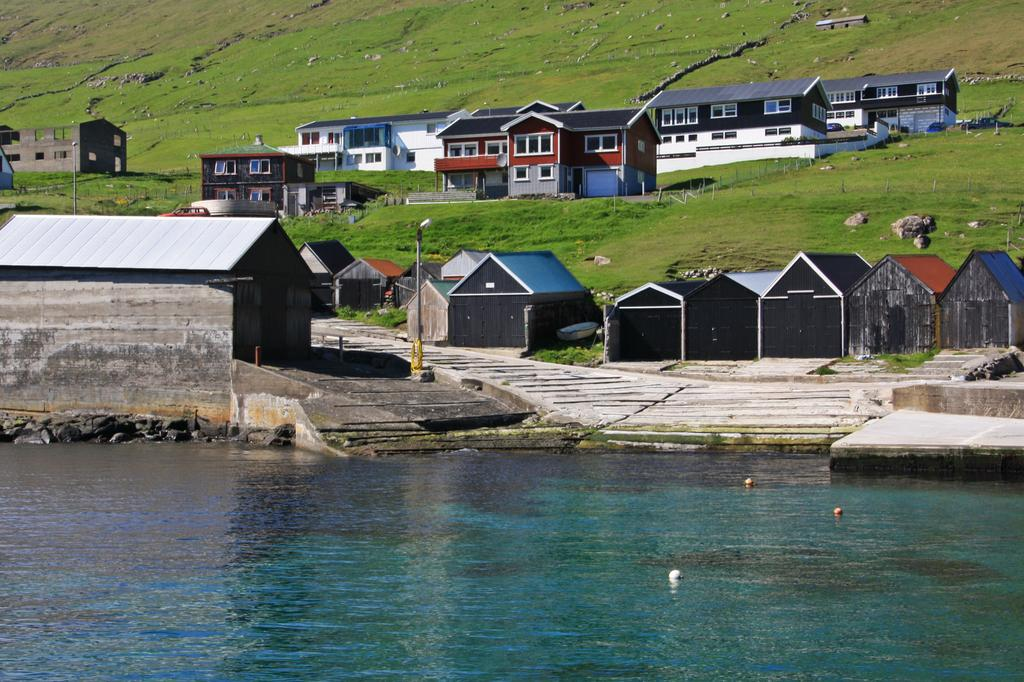What type of structures can be seen in the image? There are buildings in the image. What else can be seen in the image besides buildings? There are poles, grass, other objects on the ground, and water visible in the image. Can you describe the ground in the image? The ground is covered with grass and other objects. What is the nature of the water visible in the image? The water is not described in detail, but it is visible in the image. What type of business does the minister run in the image? There is no mention of a minister or a business in the image. The image primarily features buildings, poles, grass, other objects on the ground, and water. 